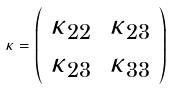<formula> <loc_0><loc_0><loc_500><loc_500>\kappa = \left ( \begin{array} { c c } \kappa _ { 2 2 } & \kappa _ { 2 3 } \\ \kappa _ { 2 3 } & \kappa _ { 3 3 } \end{array} \right )</formula> 